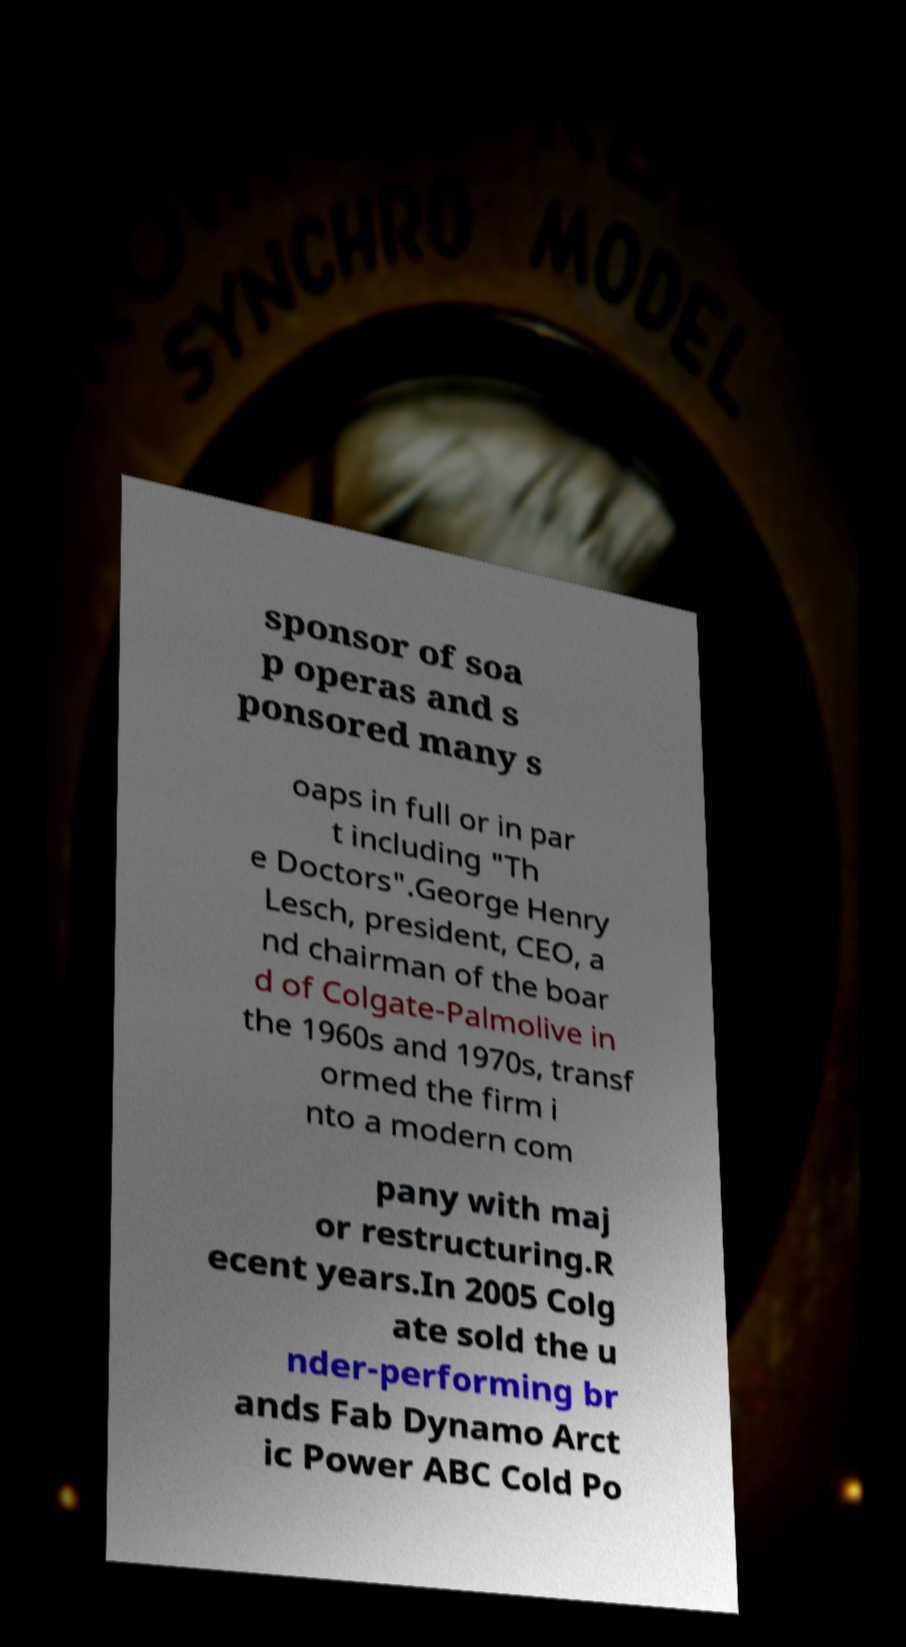Can you read and provide the text displayed in the image?This photo seems to have some interesting text. Can you extract and type it out for me? sponsor of soa p operas and s ponsored many s oaps in full or in par t including "Th e Doctors".George Henry Lesch, president, CEO, a nd chairman of the boar d of Colgate-Palmolive in the 1960s and 1970s, transf ormed the firm i nto a modern com pany with maj or restructuring.R ecent years.In 2005 Colg ate sold the u nder-performing br ands Fab Dynamo Arct ic Power ABC Cold Po 